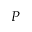<formula> <loc_0><loc_0><loc_500><loc_500>P</formula> 